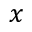<formula> <loc_0><loc_0><loc_500><loc_500>x</formula> 